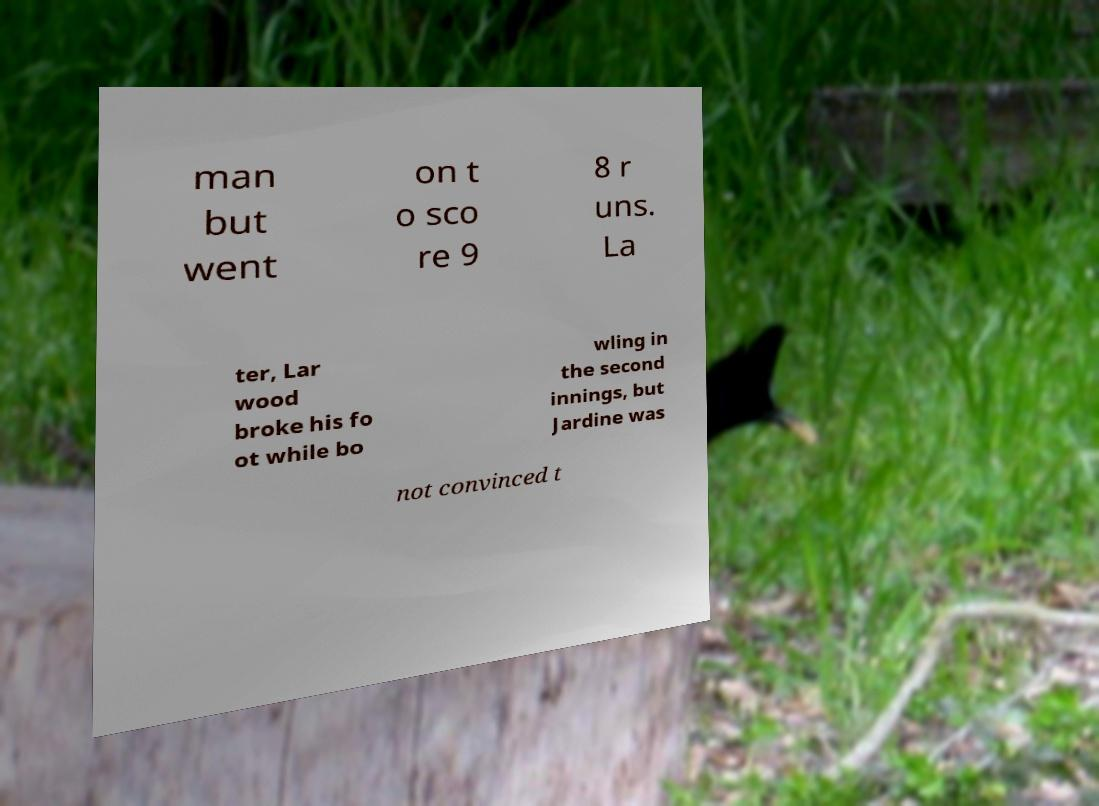What messages or text are displayed in this image? I need them in a readable, typed format. man but went on t o sco re 9 8 r uns. La ter, Lar wood broke his fo ot while bo wling in the second innings, but Jardine was not convinced t 